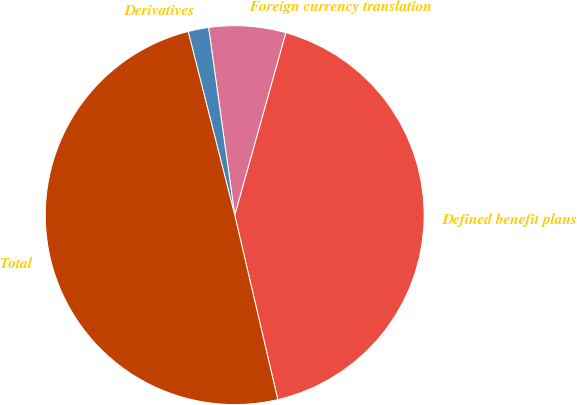<chart> <loc_0><loc_0><loc_500><loc_500><pie_chart><fcel>Defined benefit plans<fcel>Foreign currency translation<fcel>Derivatives<fcel>Total<nl><fcel>42.0%<fcel>6.55%<fcel>1.75%<fcel>49.7%<nl></chart> 